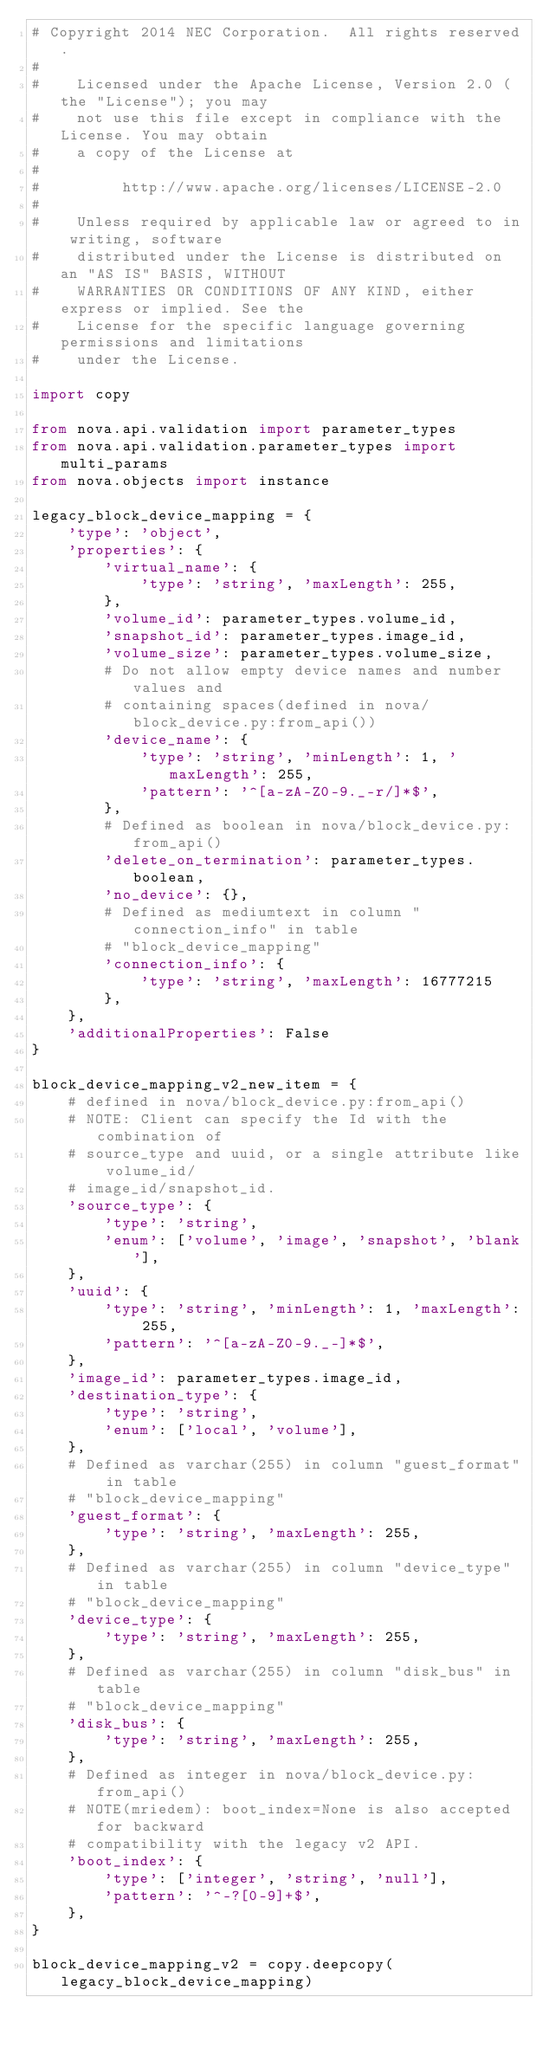<code> <loc_0><loc_0><loc_500><loc_500><_Python_># Copyright 2014 NEC Corporation.  All rights reserved.
#
#    Licensed under the Apache License, Version 2.0 (the "License"); you may
#    not use this file except in compliance with the License. You may obtain
#    a copy of the License at
#
#         http://www.apache.org/licenses/LICENSE-2.0
#
#    Unless required by applicable law or agreed to in writing, software
#    distributed under the License is distributed on an "AS IS" BASIS, WITHOUT
#    WARRANTIES OR CONDITIONS OF ANY KIND, either express or implied. See the
#    License for the specific language governing permissions and limitations
#    under the License.

import copy

from nova.api.validation import parameter_types
from nova.api.validation.parameter_types import multi_params
from nova.objects import instance

legacy_block_device_mapping = {
    'type': 'object',
    'properties': {
        'virtual_name': {
            'type': 'string', 'maxLength': 255,
        },
        'volume_id': parameter_types.volume_id,
        'snapshot_id': parameter_types.image_id,
        'volume_size': parameter_types.volume_size,
        # Do not allow empty device names and number values and
        # containing spaces(defined in nova/block_device.py:from_api())
        'device_name': {
            'type': 'string', 'minLength': 1, 'maxLength': 255,
            'pattern': '^[a-zA-Z0-9._-r/]*$',
        },
        # Defined as boolean in nova/block_device.py:from_api()
        'delete_on_termination': parameter_types.boolean,
        'no_device': {},
        # Defined as mediumtext in column "connection_info" in table
        # "block_device_mapping"
        'connection_info': {
            'type': 'string', 'maxLength': 16777215
        },
    },
    'additionalProperties': False
}

block_device_mapping_v2_new_item = {
    # defined in nova/block_device.py:from_api()
    # NOTE: Client can specify the Id with the combination of
    # source_type and uuid, or a single attribute like volume_id/
    # image_id/snapshot_id.
    'source_type': {
        'type': 'string',
        'enum': ['volume', 'image', 'snapshot', 'blank'],
    },
    'uuid': {
        'type': 'string', 'minLength': 1, 'maxLength': 255,
        'pattern': '^[a-zA-Z0-9._-]*$',
    },
    'image_id': parameter_types.image_id,
    'destination_type': {
        'type': 'string',
        'enum': ['local', 'volume'],
    },
    # Defined as varchar(255) in column "guest_format" in table
    # "block_device_mapping"
    'guest_format': {
        'type': 'string', 'maxLength': 255,
    },
    # Defined as varchar(255) in column "device_type" in table
    # "block_device_mapping"
    'device_type': {
        'type': 'string', 'maxLength': 255,
    },
    # Defined as varchar(255) in column "disk_bus" in table
    # "block_device_mapping"
    'disk_bus': {
        'type': 'string', 'maxLength': 255,
    },
    # Defined as integer in nova/block_device.py:from_api()
    # NOTE(mriedem): boot_index=None is also accepted for backward
    # compatibility with the legacy v2 API.
    'boot_index': {
        'type': ['integer', 'string', 'null'],
        'pattern': '^-?[0-9]+$',
    },
}

block_device_mapping_v2 = copy.deepcopy(legacy_block_device_mapping)</code> 